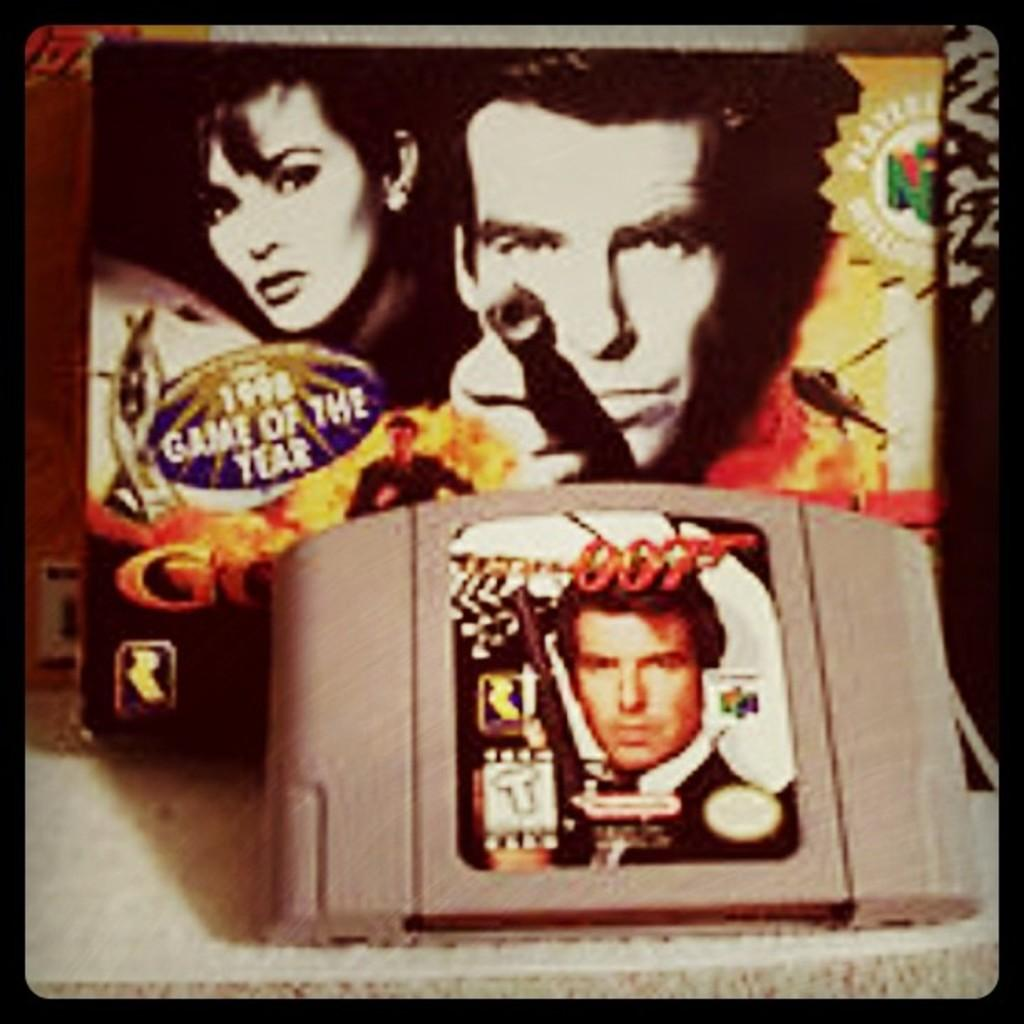How was the image altered or modified? The image is edited. What can be seen in the image besides the edited elements? There is a gadget and another object in the image. What is on the gadget in the image? The gadget has a poster on it. What is depicted on the other object in the image? The object has pictures of two people and some text. Can you see any toes in the image? There are no toes visible in the image. Is the image taken in a library or wilderness setting? The image does not depict a library or wilderness setting; it focuses on the edited elements and the objects in the image. 